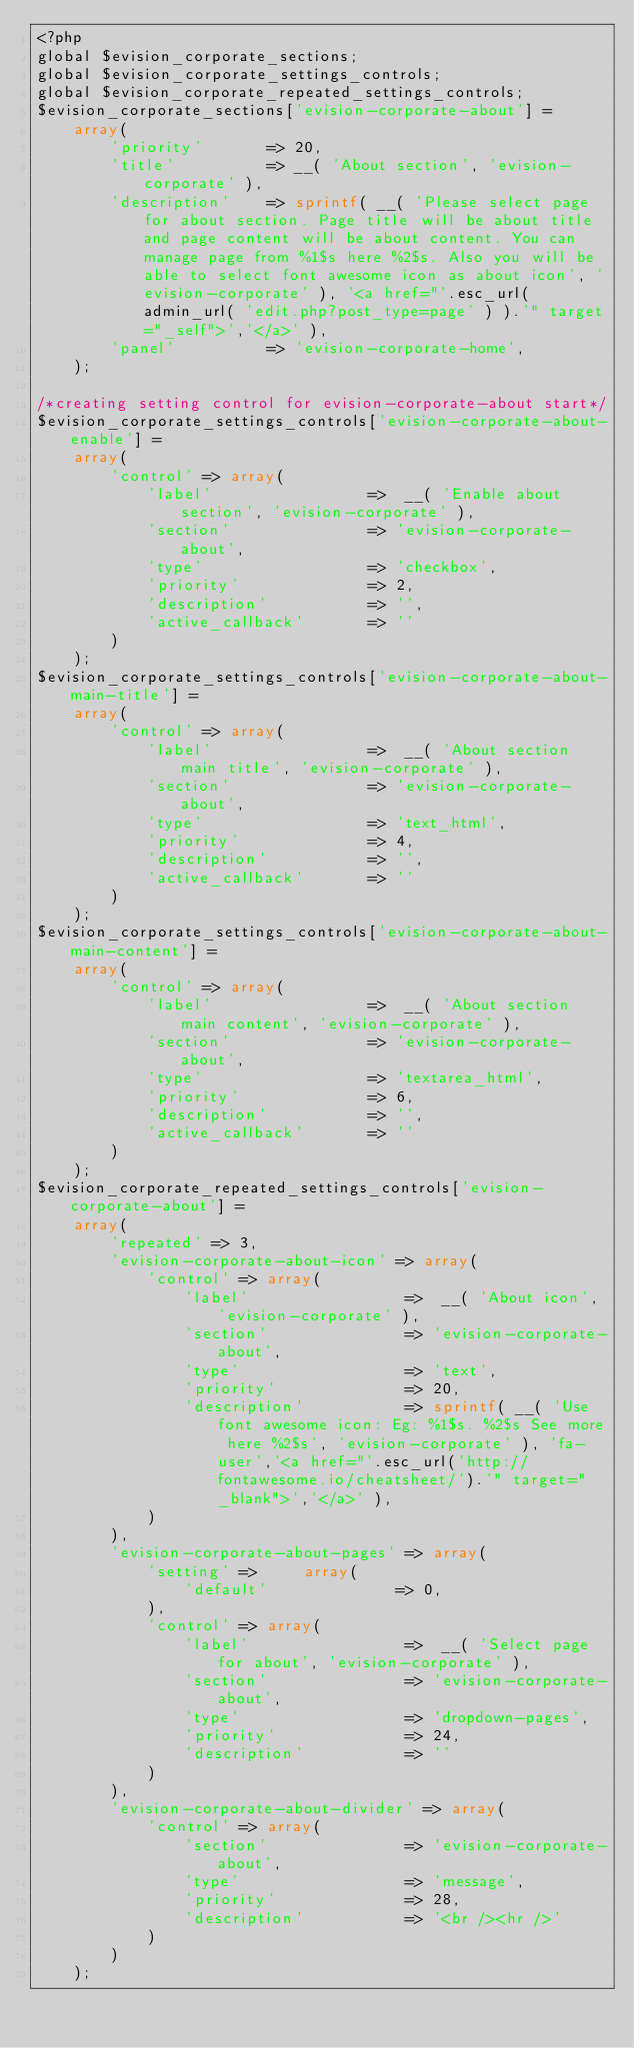<code> <loc_0><loc_0><loc_500><loc_500><_PHP_><?php
global $evision_corporate_sections;
global $evision_corporate_settings_controls;
global $evision_corporate_repeated_settings_controls;
$evision_corporate_sections['evision-corporate-about'] =
    array(
        'priority'       => 20,
        'title'          => __( 'About section', 'evision-corporate' ),
        'description'    => sprintf( __( 'Please select page for about section. Page title will be about title and page content will be about content. You can manage page from %1$s here %2$s. Also you will be able to select font awesome icon as about icon', 'evision-corporate' ), '<a href="'.esc_url( admin_url( 'edit.php?post_type=page' ) ).'" target="_self">','</a>' ),
        'panel'          => 'evision-corporate-home',
    );

/*creating setting control for evision-corporate-about start*/
$evision_corporate_settings_controls['evision-corporate-about-enable'] =
    array(
        'control' => array(
            'label'                 =>  __( 'Enable about section', 'evision-corporate' ),
            'section'               => 'evision-corporate-about',
            'type'                  => 'checkbox',
            'priority'              => 2,
            'description'           => '',
            'active_callback'       => ''
        )
    );
$evision_corporate_settings_controls['evision-corporate-about-main-title'] =
    array(
        'control' => array(
            'label'                 =>  __( 'About section main title', 'evision-corporate' ),
            'section'               => 'evision-corporate-about',
            'type'                  => 'text_html',
            'priority'              => 4,
            'description'           => '',
            'active_callback'       => ''
        )
    );
$evision_corporate_settings_controls['evision-corporate-about-main-content'] =
    array(
        'control' => array(
            'label'                 =>  __( 'About section main content', 'evision-corporate' ),
            'section'               => 'evision-corporate-about',
            'type'                  => 'textarea_html',
            'priority'              => 6,
            'description'           => '',
            'active_callback'       => ''
        )
    );
$evision_corporate_repeated_settings_controls['evision-corporate-about'] =
    array(
        'repeated' => 3,
        'evision-corporate-about-icon' => array(
            'control' => array(
                'label'                 =>  __( 'About icon', 'evision-corporate' ),
                'section'               => 'evision-corporate-about',
                'type'                  => 'text',
                'priority'              => 20,
                'description'           => sprintf( __( 'Use font awesome icon: Eg: %1$s. %2$s See more here %2$s', 'evision-corporate' ), 'fa-user','<a href="'.esc_url('http://fontawesome.io/cheatsheet/').'" target="_blank">','</a>' ),
            )
        ),
        'evision-corporate-about-pages' => array(
            'setting' =>     array(
                'default'              => 0,
            ),
            'control' => array(
                'label'                 =>  __( 'Select page for about', 'evision-corporate' ),
                'section'               => 'evision-corporate-about',
                'type'                  => 'dropdown-pages',
                'priority'              => 24,
                'description'           => ''
            )
        ),
        'evision-corporate-about-divider' => array(
            'control' => array(
                'section'               => 'evision-corporate-about',
                'type'                  => 'message',
                'priority'              => 28,
                'description'           => '<br /><hr />'
            )
        )
    );</code> 